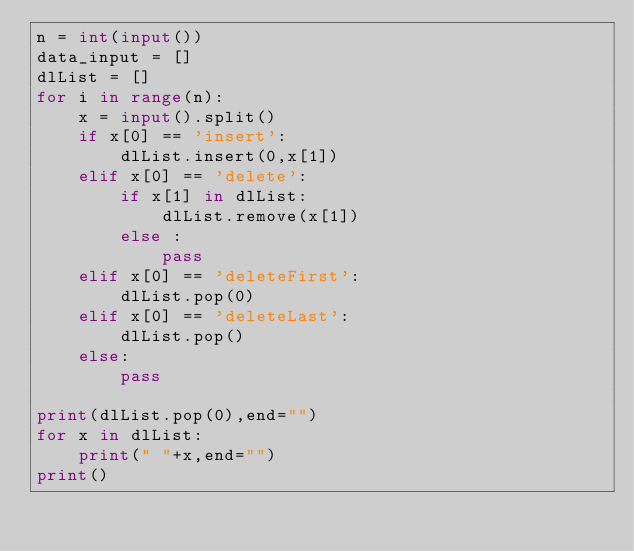Convert code to text. <code><loc_0><loc_0><loc_500><loc_500><_Python_>n = int(input())
data_input = []
dlList = []
for i in range(n):
    x = input().split()
    if x[0] == 'insert':
        dlList.insert(0,x[1])
    elif x[0] == 'delete':
        if x[1] in dlList:
            dlList.remove(x[1])
        else :
            pass
    elif x[0] == 'deleteFirst':
        dlList.pop(0)
    elif x[0] == 'deleteLast':
        dlList.pop()
    else:
        pass

print(dlList.pop(0),end="")
for x in dlList:
    print(" "+x,end="")
print()</code> 